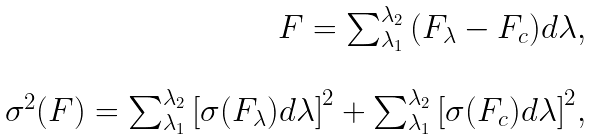Convert formula to latex. <formula><loc_0><loc_0><loc_500><loc_500>\begin{array} { r } F = \sum _ { \lambda _ { 1 } } ^ { \lambda _ { 2 } } { ( F _ { \lambda } - F _ { c } ) d \lambda } , \\ \\ \sigma ^ { 2 } ( F ) = \sum _ { \lambda _ { 1 } } ^ { \lambda _ { 2 } } { \left [ \sigma ( F _ { \lambda } ) d \lambda \right ] ^ { 2 } } + \sum _ { \lambda _ { 1 } } ^ { \lambda _ { 2 } } { \left [ \sigma ( F _ { c } ) d \lambda \right ] ^ { 2 } } , \end{array}</formula> 